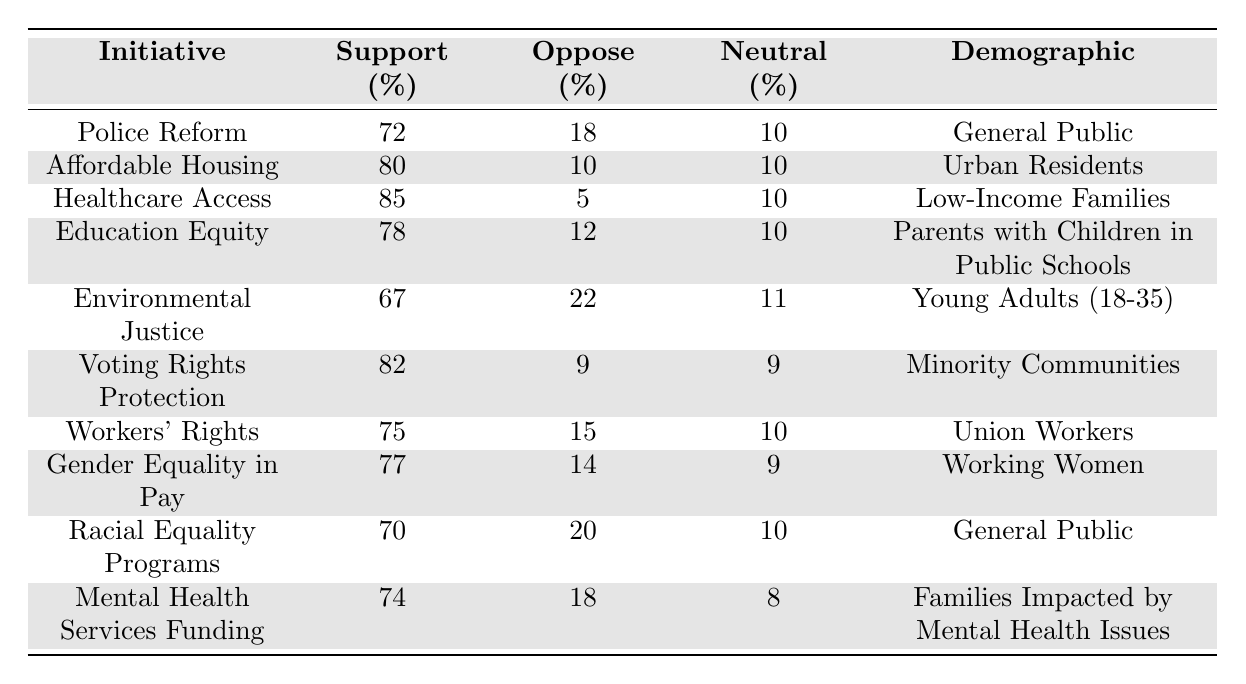What percentage of the general public supports Police Reform? The table lists the support percentage for Police Reform under the "General Public" demographic, which is stated as 72%.
Answer: 72% What percentage of Low-Income Families oppose Healthcare Access? The table indicates that the oppose percentage for Healthcare Access among Low-Income Families is 5%.
Answer: 5% Which initiative has the highest support percentage? By examining the support percentages, Healthcare Access has the highest at 85%.
Answer: 85% What is the neutral percentage for Voting Rights Protection among Minority Communities? The table shows that the neutral percentage for Voting Rights Protection in Minority Communities is 9%.
Answer: 9% What is the difference between support percentages for Gender Equality in Pay and Racial Equality Programs? The support for Gender Equality in Pay is 77%, and for Racial Equality Programs, it is 70%. The difference is 77% - 70% = 7%.
Answer: 7% Which initiative has a higher oppose percentage: Environmental Justice or Workers' Rights? The oppose percentage for Environmental Justice is 22%, while for Workers' Rights, it is 15%. Since 22% > 15%, Environmental Justice has a higher oppose percentage.
Answer: Environmental Justice What percentage of Urban Residents are neutral about Affordable Housing? According to the table, the neutral percentage of Urban Residents regarding Affordable Housing is 10%.
Answer: 10% How many initiatives have a support percentage of at least 75%? By reviewing the support percentages, the initiatives with 75% or more are Healthcare Access (85%), Affordable Housing (80%), Voting Rights Protection (82%), Workers' Rights (75%), Gender Equality in Pay (77%), and Education Equity (78%). Counting these gives us 6 initiatives.
Answer: 6 What percentage of Parents with Children in Public Schools oppose Education Equity? The oppose percentage for Education Equity under that demographic is listed as 12%.
Answer: 12% Is the support for Mental Health Services Funding higher than that for Environmental Justice? Mental Health Services Funding has a support percentage of 74%, while Environmental Justice has 67%. Since 74% > 67%, the support for Mental Health Services Funding is higher.
Answer: Yes What is the average support percentage for all initiatives listed for the General Public? The support percentages for the General Public initiatives are 72% (Police Reform) and 70% (Racial Equality Programs). The average is (72% + 70%) / 2 = 71%.
Answer: 71% 